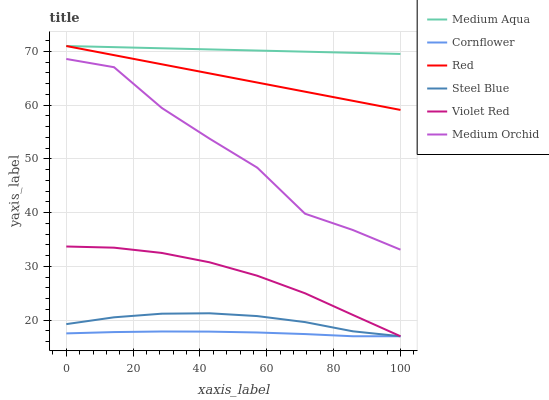Does Cornflower have the minimum area under the curve?
Answer yes or no. Yes. Does Medium Aqua have the maximum area under the curve?
Answer yes or no. Yes. Does Violet Red have the minimum area under the curve?
Answer yes or no. No. Does Violet Red have the maximum area under the curve?
Answer yes or no. No. Is Red the smoothest?
Answer yes or no. Yes. Is Medium Orchid the roughest?
Answer yes or no. Yes. Is Violet Red the smoothest?
Answer yes or no. No. Is Violet Red the roughest?
Answer yes or no. No. Does Cornflower have the lowest value?
Answer yes or no. Yes. Does Medium Orchid have the lowest value?
Answer yes or no. No. Does Red have the highest value?
Answer yes or no. Yes. Does Violet Red have the highest value?
Answer yes or no. No. Is Steel Blue less than Medium Aqua?
Answer yes or no. Yes. Is Red greater than Violet Red?
Answer yes or no. Yes. Does Red intersect Medium Aqua?
Answer yes or no. Yes. Is Red less than Medium Aqua?
Answer yes or no. No. Is Red greater than Medium Aqua?
Answer yes or no. No. Does Steel Blue intersect Medium Aqua?
Answer yes or no. No. 